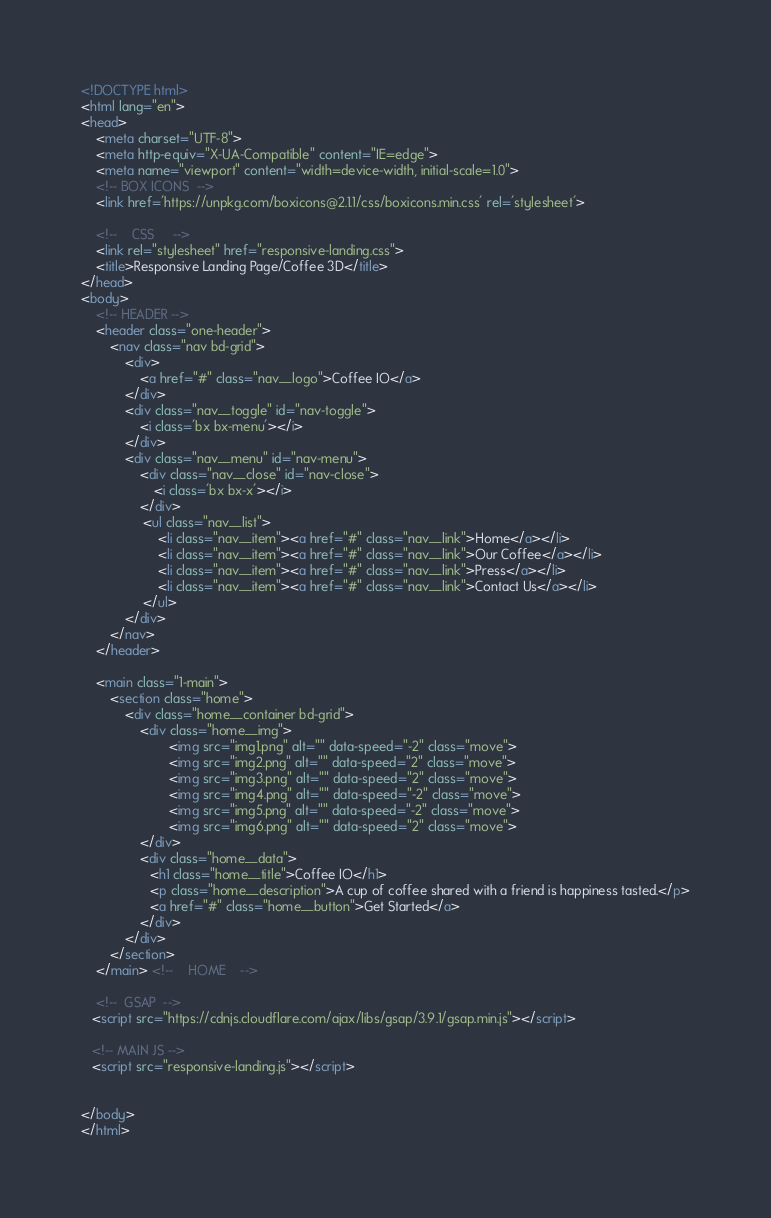Convert code to text. <code><loc_0><loc_0><loc_500><loc_500><_HTML_><!DOCTYPE html>
<html lang="en">
<head>
    <meta charset="UTF-8">
    <meta http-equiv="X-UA-Compatible" content="IE=edge">
    <meta name="viewport" content="width=device-width, initial-scale=1.0">
    <!-- BOX ICONS  -->
    <link href='https://unpkg.com/boxicons@2.1.1/css/boxicons.min.css' rel='stylesheet'>

    <!--    CSS     -->
    <link rel="stylesheet" href="responsive-landing.css">
    <title>Responsive Landing Page/Coffee 3D</title>
</head>
<body>
    <!-- HEADER -->
    <header class="one-header">
        <nav class="nav bd-grid">
            <div>
                <a href="#" class="nav__logo">Coffee IO</a>
            </div>
            <div class="nav__toggle" id="nav-toggle">
                <i class='bx bx-menu'></i>
            </div>
            <div class="nav__menu" id="nav-menu">
                <div class="nav__close" id="nav-close">
                    <i class='bx bx-x'></i>
                </div>
                 <ul class="nav__list">
                     <li class="nav__item"><a href="#" class="nav__link">Home</a></li>
                     <li class="nav__item"><a href="#" class="nav__link">Our Coffee</a></li>
                     <li class="nav__item"><a href="#" class="nav__link">Press</a></li>
                     <li class="nav__item"><a href="#" class="nav__link">Contact Us</a></li>
                 </ul>
            </div>
        </nav>
    </header>

    <main class="1-main">
        <section class="home">
            <div class="home__container bd-grid">
                <div class="home__img">
                        <img src="img1.png" alt="" data-speed="-2" class="move">
                        <img src="img2.png" alt="" data-speed="2" class="move">
                        <img src="img3.png" alt="" data-speed="2" class="move">
                        <img src="img4.png" alt="" data-speed="-2" class="move">
                        <img src="img5.png" alt="" data-speed="-2" class="move">
                        <img src="img6.png" alt="" data-speed="2" class="move">
                </div>
                <div class="home__data">
                   <h1 class="home__title">Coffee IO</h1>
                   <p class="home__description">A cup of coffee shared with a friend is happiness tasted.</p>
                   <a href="#" class="home__button">Get Started</a>
                </div>
            </div>
        </section>
    </main> <!--    HOME    -->

    <!--  GSAP  -->
   <script src="https://cdnjs.cloudflare.com/ajax/libs/gsap/3.9.1/gsap.min.js"></script>

   <!-- MAIN JS -->
   <script src="responsive-landing.js"></script>


</body>
</html>


</code> 